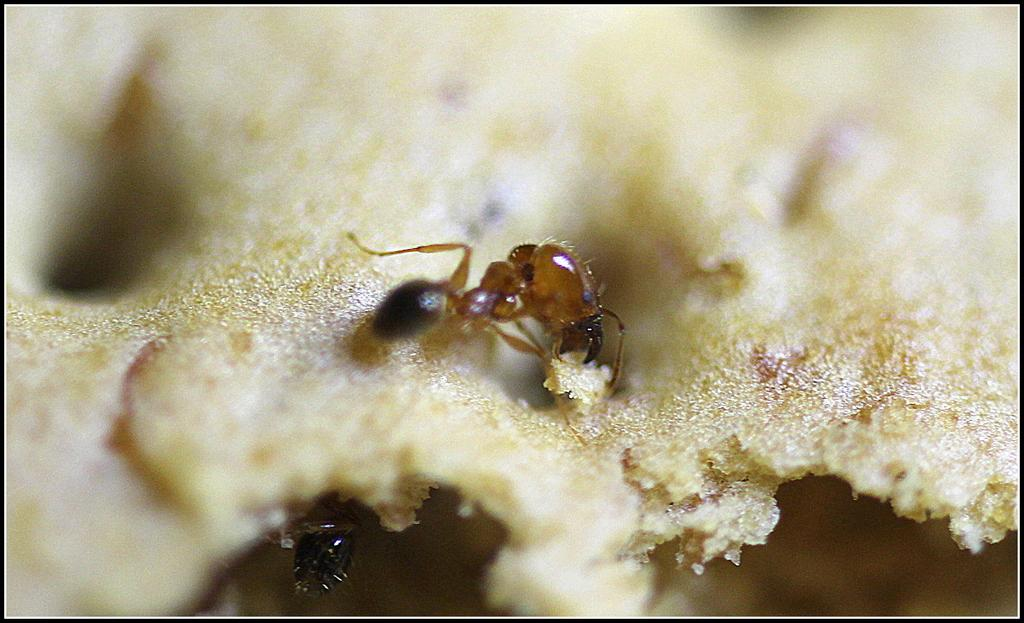What is happening to the food in the image? There are ants on the food in the image. Can you describe the background of the image? The background is blurred in the image. Where is the lunchroom in the image? There is no mention of a lunchroom in the image, so we cannot determine its location. What type of war is depicted in the image? There is no war or any indication of conflict in the image. 